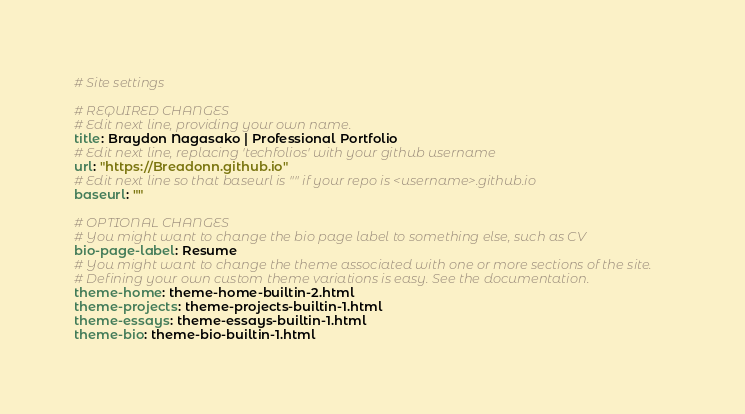<code> <loc_0><loc_0><loc_500><loc_500><_YAML_># Site settings

# REQUIRED CHANGES
# Edit next line, providing your own name.
title: Braydon Nagasako | Professional Portfolio
# Edit next line, replacing 'techfolios' with your github username
url: "https://Breadonn.github.io"
# Edit next line so that baseurl is "" if your repo is <username>.github.io
baseurl: ""

# OPTIONAL CHANGES
# You might want to change the bio page label to something else, such as CV
bio-page-label: Resume
# You might want to change the theme associated with one or more sections of the site.
# Defining your own custom theme variations is easy. See the documentation.
theme-home: theme-home-builtin-2.html
theme-projects: theme-projects-builtin-1.html
theme-essays: theme-essays-builtin-1.html
theme-bio: theme-bio-builtin-1.html
</code> 